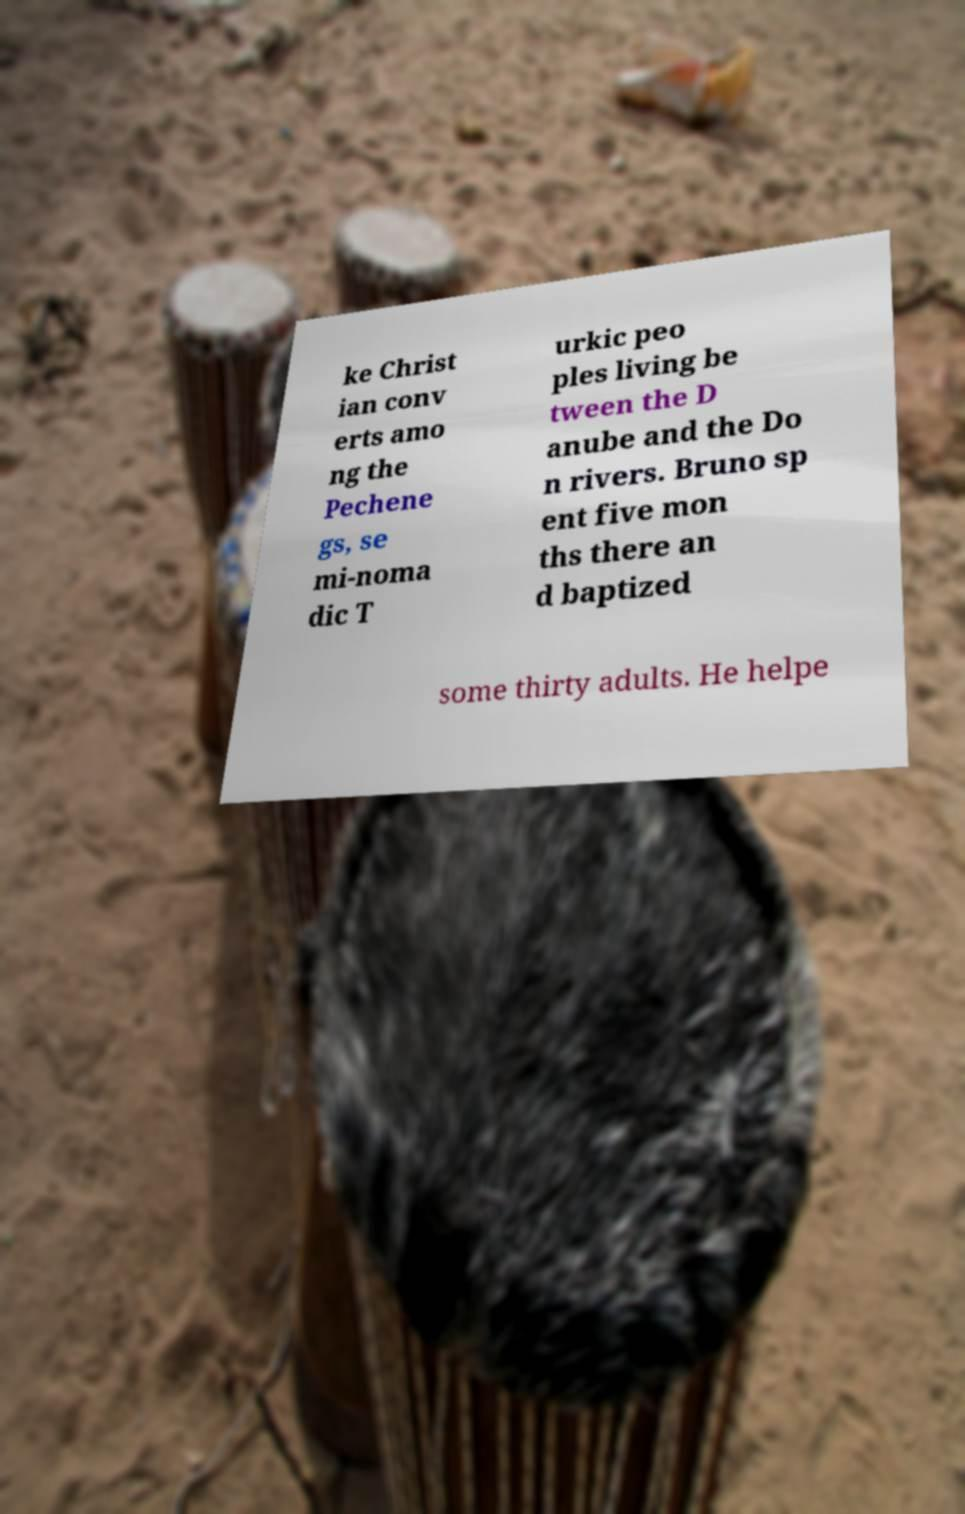Could you extract and type out the text from this image? ke Christ ian conv erts amo ng the Pechene gs, se mi-noma dic T urkic peo ples living be tween the D anube and the Do n rivers. Bruno sp ent five mon ths there an d baptized some thirty adults. He helpe 